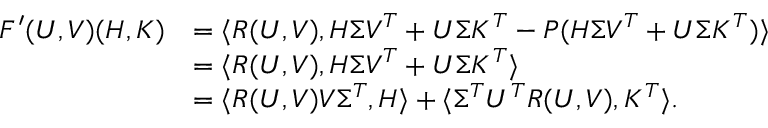<formula> <loc_0><loc_0><loc_500><loc_500>\begin{array} { r l } { F ^ { \prime } ( U , V ) ( H , K ) } & { = \langle R ( U , V ) , H \Sigma V ^ { T } + U \Sigma K ^ { T } - P ( H \Sigma V ^ { T } + U \Sigma K ^ { T } ) \rangle } \\ & { = \langle R ( U , V ) , H \Sigma V ^ { T } + U \Sigma K ^ { T } \rangle } \\ & { = \langle R ( U , V ) V \Sigma ^ { T } , H \rangle + \langle \Sigma ^ { T } U ^ { T } R ( U , V ) , K ^ { T } \rangle . } \end{array}</formula> 